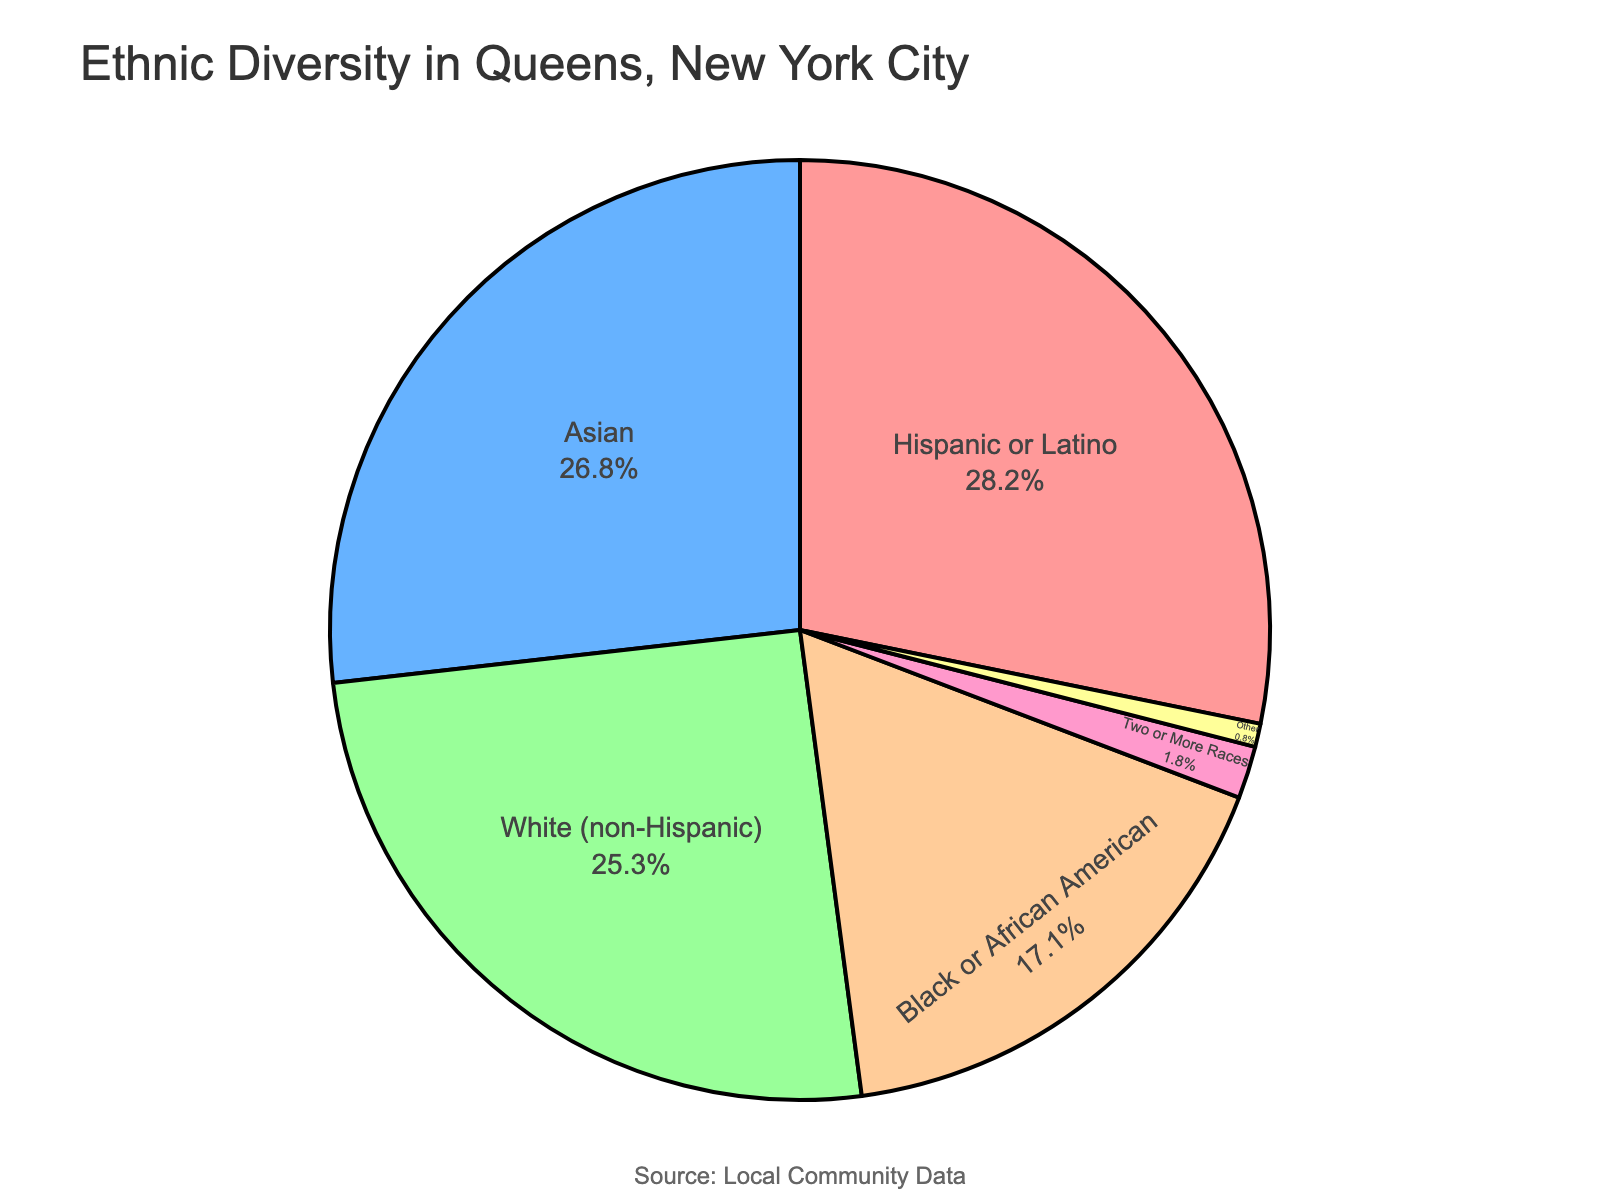What percentage of the population in Queens is Asian? Look at the pie chart section labeled "Asian" and check the corresponding percentage.
Answer: 26.8% Which ethnic group has the smallest representation in Queens? Find the smallest wedge in the pie chart and check the label. It is "Other" with a percentage of 0.8%.
Answer: Other How much larger is the Hispanic or Latino population compared to the Black or African American population? Subtract the percentage of Black or African American (17.1%) from the percentage of Hispanic or Latino (28.2%).
Answer: 11.1% What is the combined percentage of white (non-Hispanic) and Asian populations in Queens? Add the percentages of White (non-Hispanic) (25.3%) and Asian (26.8%).
Answer: 52.1% How does the representation of Two or More Races compare to the representation of Other ethnic groups? Look at the percentages for Two or More Races (1.8%) and Other (0.8%) and determine which is larger. Two or More Races is larger by 1.0%.
Answer: Two or More Races is larger by 1.0% Is the Hispanic or Latino population larger than the Asian population? Compare the percentages for Hispanic or Latino (28.2%) and Asian (26.8%). The Hispanic or Latino population is larger.
Answer: Yes What is the total percentage of ethnic groups other than Hispanic or Latino, White (non-Hispanic), and Asian? Calculate the total by adding the percentages of Black or African American (17.1%), Two or More Races (1.8%), and Other (0.8%).
Answer: 19.7% How much higher is the percentage of White (non-Hispanic) compared to the percentage of Two or More Races? Subtract the percentage of Two or More Races (1.8%) from the percentage of White (non-Hispanic) (25.3%).
Answer: 23.5% What color represents the Hispanic or Latino group in the pie chart? Identify the color by looking for the section labeled "Hispanic or Latino" in the pie chart.
Answer: Red Which group has a higher representation, White (non-Hispanic) or Black or African American? Compare the percentages of White (non-Hispanic) (25.3%) and Black or African American (17.1%). White (non-Hispanic) has a higher representation.
Answer: White (non-Hispanic) 